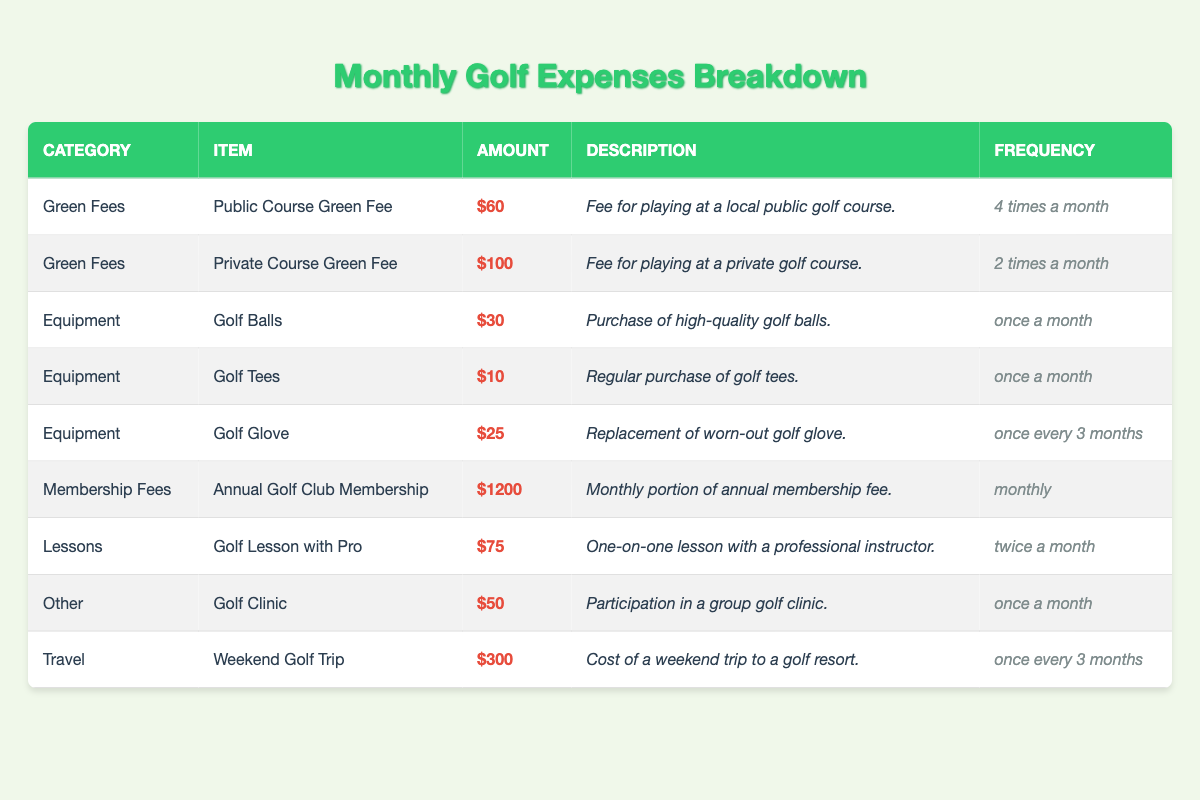What is the total cost for playing at the public course each month? The public course green fee is $60 and is paid 4 times a month. Therefore, the total cost is calculated as 60 * 4 = $240.
Answer: $240 What is the total amount spent on golf equipment per month? The total amount for equipment is from golf balls ($30), golf tees ($10), and golf glove ($25). However, the golf glove is replaced every 3 months, resulting in an average monthly cost of 25/3 = $8.33. The total equipment cost is then 30 + 10 + 8.33 = $48.33.
Answer: $48.33 How much is spent on lessons each month? The golf lesson with a pro costs $75 and is taken twice a month. Thus, the total cost is calculated as 75 * 2 = $150.
Answer: $150 What is the maximum single expense item in the table? The highest expense listed is the annual golf club membership at $1200, as this amount is greater than any other individual expenses provided.
Answer: $1200 Is the total spent on green fees greater than the total spent on equipment? The total spent on green fees is $240 (public) + $200 (private) = $440. The total spent on equipment, averaged, is $48.33 per month. Since 440 > 48.33, the statement is true.
Answer: Yes What is the total monthly expense for green fees and lessons combined? The total green fees are $240 for public and $200 for private, which sums to 240 + 200 = $440. The lessons cost $150. Adding these together gives 440 + 150 = $590.
Answer: $590 What is the average expense for golf balls and tees combined? The cost for golf balls is $30 and for golf tees is $10. Summing these gives 30 + 10 = $40. Since there are 2 items, the average is 40/2 = $20.
Answer: $20 Are the travel costs paid monthly? The travel cost for the weekend golf trip amounts to $300 but is set to once every 3 months. Thus, the effective monthly expense would be 300/3, which is $100. Since it is not paid monthly, the statement is false.
Answer: No If I take a golf lesson and go to a golf clinic this month, how much will I spend in total on those two activities? The cost of the golf lesson is $75 and the golf clinic is $50. Adding these together gives 75 + 50 = $125.
Answer: $125 What is the total amount spent on membership fees over the year? The monthly portion of the annual membership fee is $1200. To find the yearly cost, multiply by 12 months: 1200 * 12 = $14,400.
Answer: $14,400 What is the frequency of replacing the golf glove? The golf glove is noted to be replaced once every 3 months, meaning it will typically require purchasing 4 times a year for replacement.
Answer: Once every 3 months 